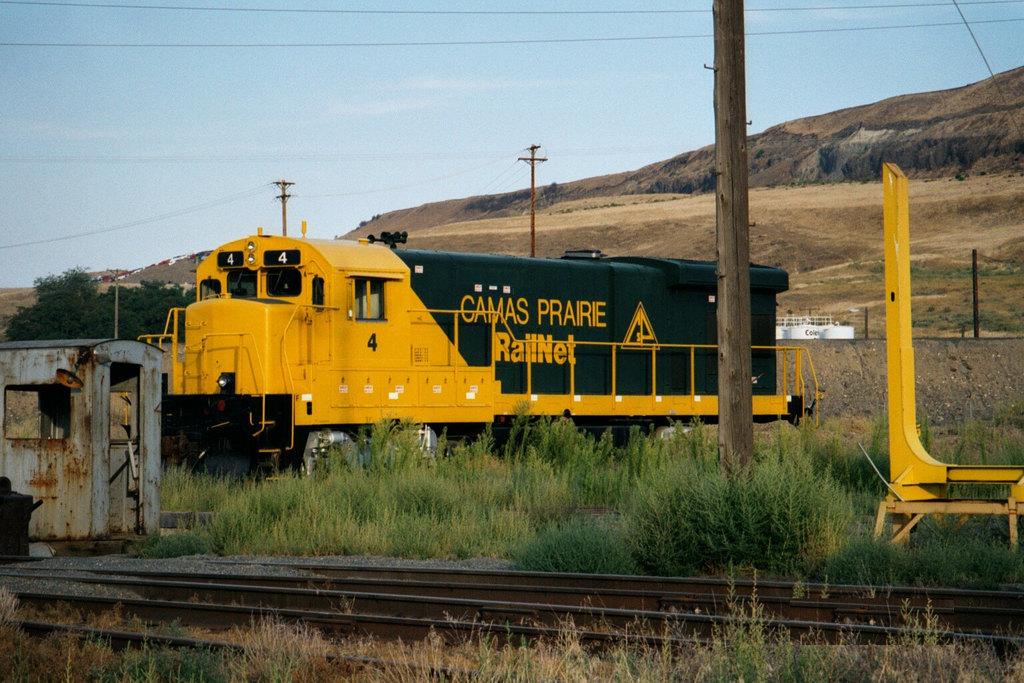What's the word before prairie?
Ensure brevity in your answer.  Camas. What is the name of this train?
Your answer should be compact. Camas prairie. 